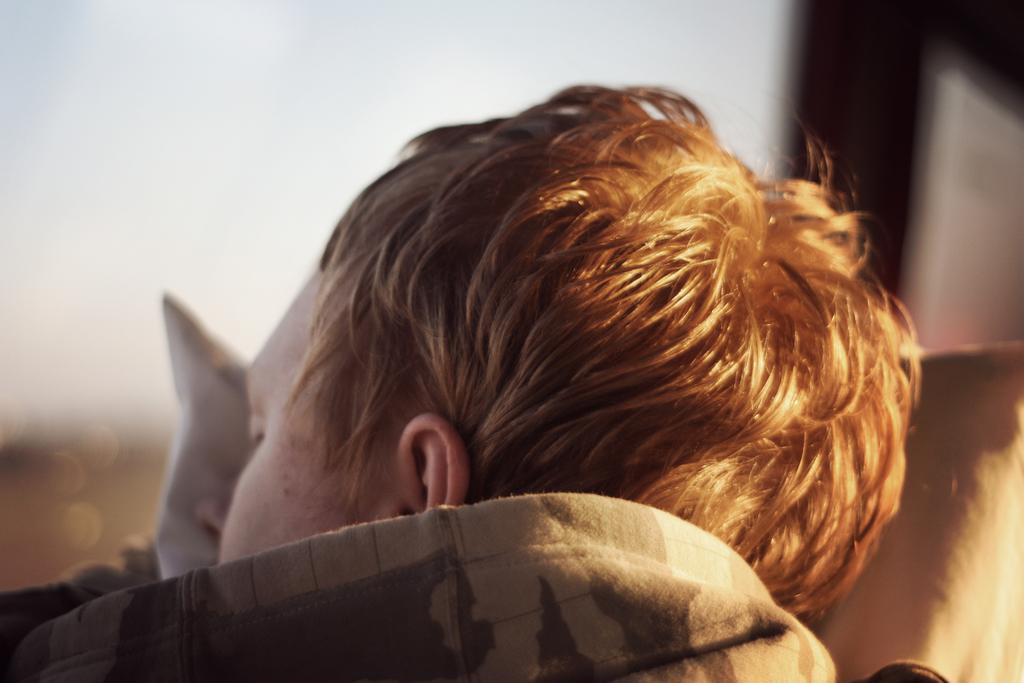Please provide a concise description of this image. In this image we can see a person sleeping on a pillow and a blurry background. 